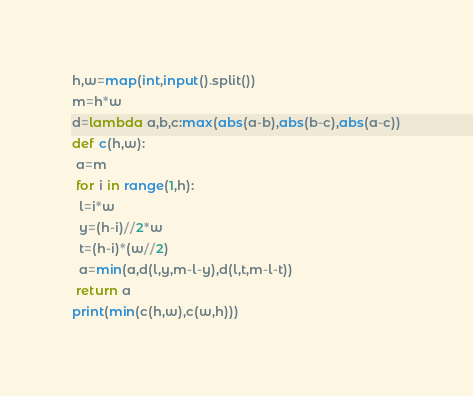Convert code to text. <code><loc_0><loc_0><loc_500><loc_500><_Python_>h,w=map(int,input().split())
m=h*w
d=lambda a,b,c:max(abs(a-b),abs(b-c),abs(a-c))
def c(h,w):
 a=m
 for i in range(1,h):
  l=i*w
  y=(h-i)//2*w
  t=(h-i)*(w//2)
  a=min(a,d(l,y,m-l-y),d(l,t,m-l-t))
 return a
print(min(c(h,w),c(w,h)))</code> 